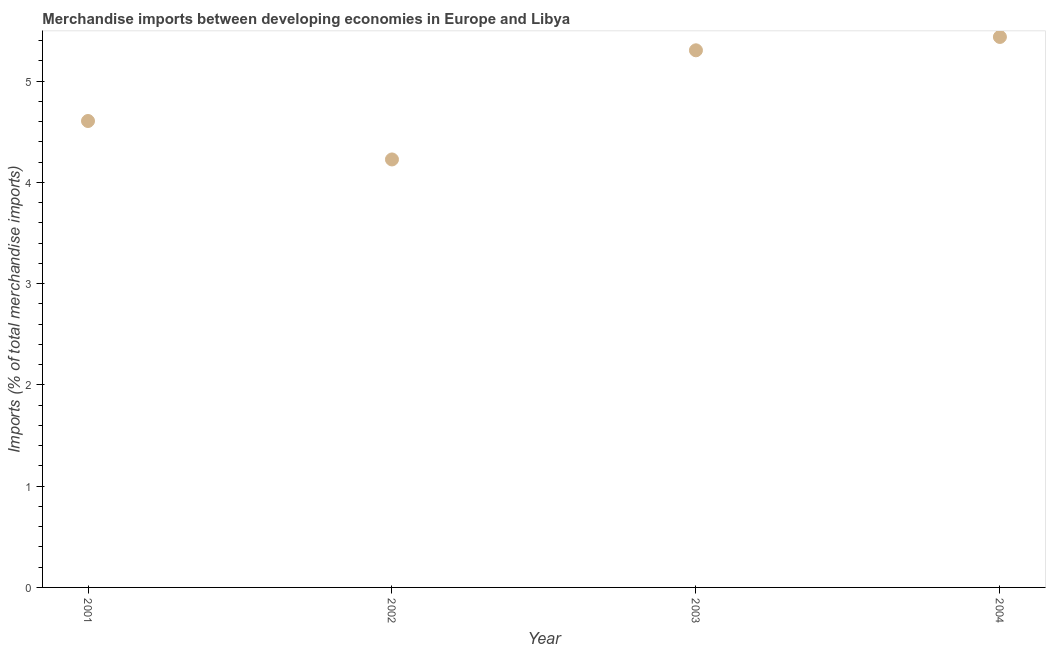What is the merchandise imports in 2002?
Offer a terse response. 4.23. Across all years, what is the maximum merchandise imports?
Your answer should be compact. 5.44. Across all years, what is the minimum merchandise imports?
Keep it short and to the point. 4.23. What is the sum of the merchandise imports?
Make the answer very short. 19.57. What is the difference between the merchandise imports in 2002 and 2003?
Ensure brevity in your answer.  -1.08. What is the average merchandise imports per year?
Give a very brief answer. 4.89. What is the median merchandise imports?
Make the answer very short. 4.95. What is the ratio of the merchandise imports in 2001 to that in 2003?
Ensure brevity in your answer.  0.87. What is the difference between the highest and the second highest merchandise imports?
Offer a very short reply. 0.13. Is the sum of the merchandise imports in 2003 and 2004 greater than the maximum merchandise imports across all years?
Offer a terse response. Yes. What is the difference between the highest and the lowest merchandise imports?
Your response must be concise. 1.21. Does the merchandise imports monotonically increase over the years?
Provide a short and direct response. No. How many dotlines are there?
Keep it short and to the point. 1. What is the difference between two consecutive major ticks on the Y-axis?
Offer a very short reply. 1. Does the graph contain any zero values?
Provide a succinct answer. No. What is the title of the graph?
Provide a succinct answer. Merchandise imports between developing economies in Europe and Libya. What is the label or title of the Y-axis?
Keep it short and to the point. Imports (% of total merchandise imports). What is the Imports (% of total merchandise imports) in 2001?
Ensure brevity in your answer.  4.61. What is the Imports (% of total merchandise imports) in 2002?
Offer a terse response. 4.23. What is the Imports (% of total merchandise imports) in 2003?
Your answer should be very brief. 5.3. What is the Imports (% of total merchandise imports) in 2004?
Offer a terse response. 5.44. What is the difference between the Imports (% of total merchandise imports) in 2001 and 2002?
Offer a very short reply. 0.38. What is the difference between the Imports (% of total merchandise imports) in 2001 and 2003?
Your response must be concise. -0.7. What is the difference between the Imports (% of total merchandise imports) in 2001 and 2004?
Offer a terse response. -0.83. What is the difference between the Imports (% of total merchandise imports) in 2002 and 2003?
Ensure brevity in your answer.  -1.08. What is the difference between the Imports (% of total merchandise imports) in 2002 and 2004?
Make the answer very short. -1.21. What is the difference between the Imports (% of total merchandise imports) in 2003 and 2004?
Your response must be concise. -0.13. What is the ratio of the Imports (% of total merchandise imports) in 2001 to that in 2002?
Your answer should be very brief. 1.09. What is the ratio of the Imports (% of total merchandise imports) in 2001 to that in 2003?
Your response must be concise. 0.87. What is the ratio of the Imports (% of total merchandise imports) in 2001 to that in 2004?
Ensure brevity in your answer.  0.85. What is the ratio of the Imports (% of total merchandise imports) in 2002 to that in 2003?
Keep it short and to the point. 0.8. What is the ratio of the Imports (% of total merchandise imports) in 2002 to that in 2004?
Provide a short and direct response. 0.78. What is the ratio of the Imports (% of total merchandise imports) in 2003 to that in 2004?
Offer a terse response. 0.98. 